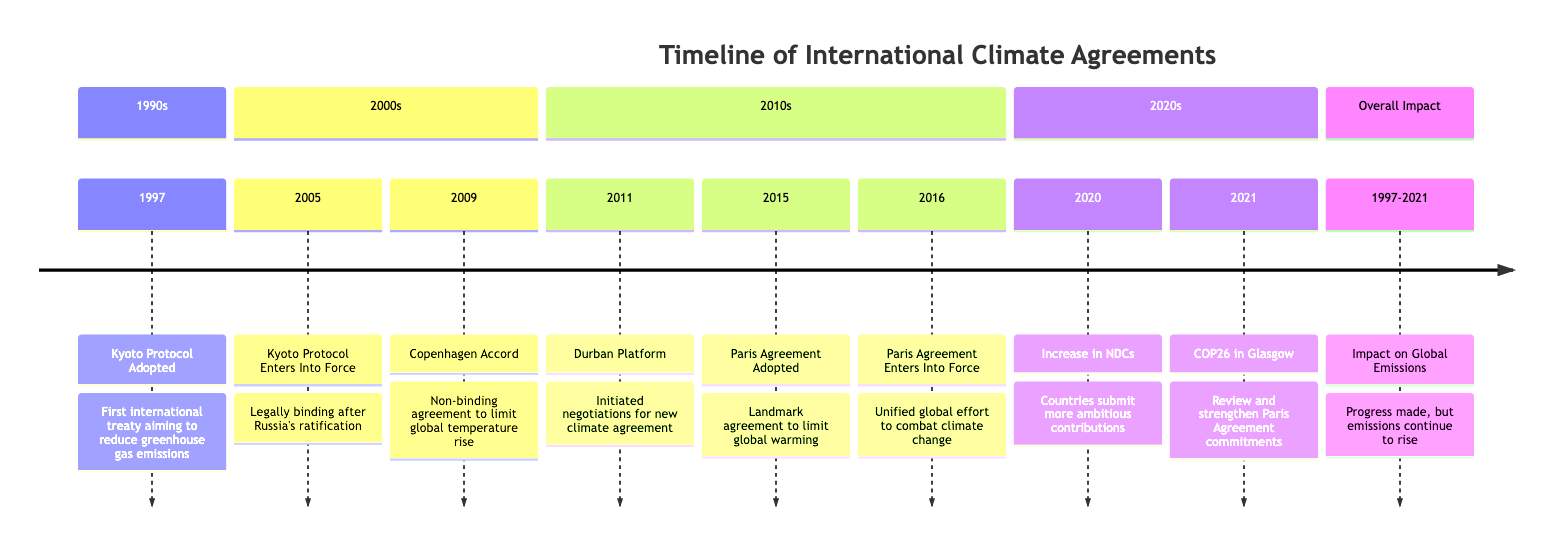What year was the Kyoto Protocol adopted? The diagram indicates that the Kyoto Protocol was adopted in the year 1997.
Answer: 1997 What significant event occurred in 2005? According to the timeline, the Kyoto Protocol entered into force in 2005 after Russia's ratification.
Answer: Kyoto Protocol Enters Into Force What was the nature of the Copenhagen Accord? The diagram shows that the Copenhagen Accord, adopted in 2009, was a non-binding agreement to limit global temperature rise.
Answer: Non-binding agreement What happened during the COP26 in Glasgow? The timeline states that during COP26 in Glasgow in 2021, countries reviewed and strengthened their commitments under the Paris Agreement.
Answer: Reviewed and strengthened commitments How many major events occurred between 1997 and 2021? By reviewing the timeline from the first event in 1997 to the last event in 2021, there are a total of eight significant events.
Answer: 8 What was the main aim of the Paris Agreement adopted in 2015? The diagram notes that the primary aim of the Paris Agreement was to limit global warming to well below 2°C, ideally to 1.5°C.
Answer: Limit global warming Which agreement initiated negotiations for a new climate treaty in 2011? The timeline states that the Durban Platform initiated negotiations for a new comprehensive climate agreement in 2011.
Answer: Durban Platform What was the overall impact on global emissions from 1997 to 2021? The diagram summarizes that while progress has been made, global emissions continued to rise during this period.
Answer: Emissions continue to rise What does NDC stand for in the context of the 2020 event? The acronym NDC refers to Nationally Determined Contributions, highlighted in the event from 2020 when countries began submitting more ambitious ones.
Answer: Nationally Determined Contributions 